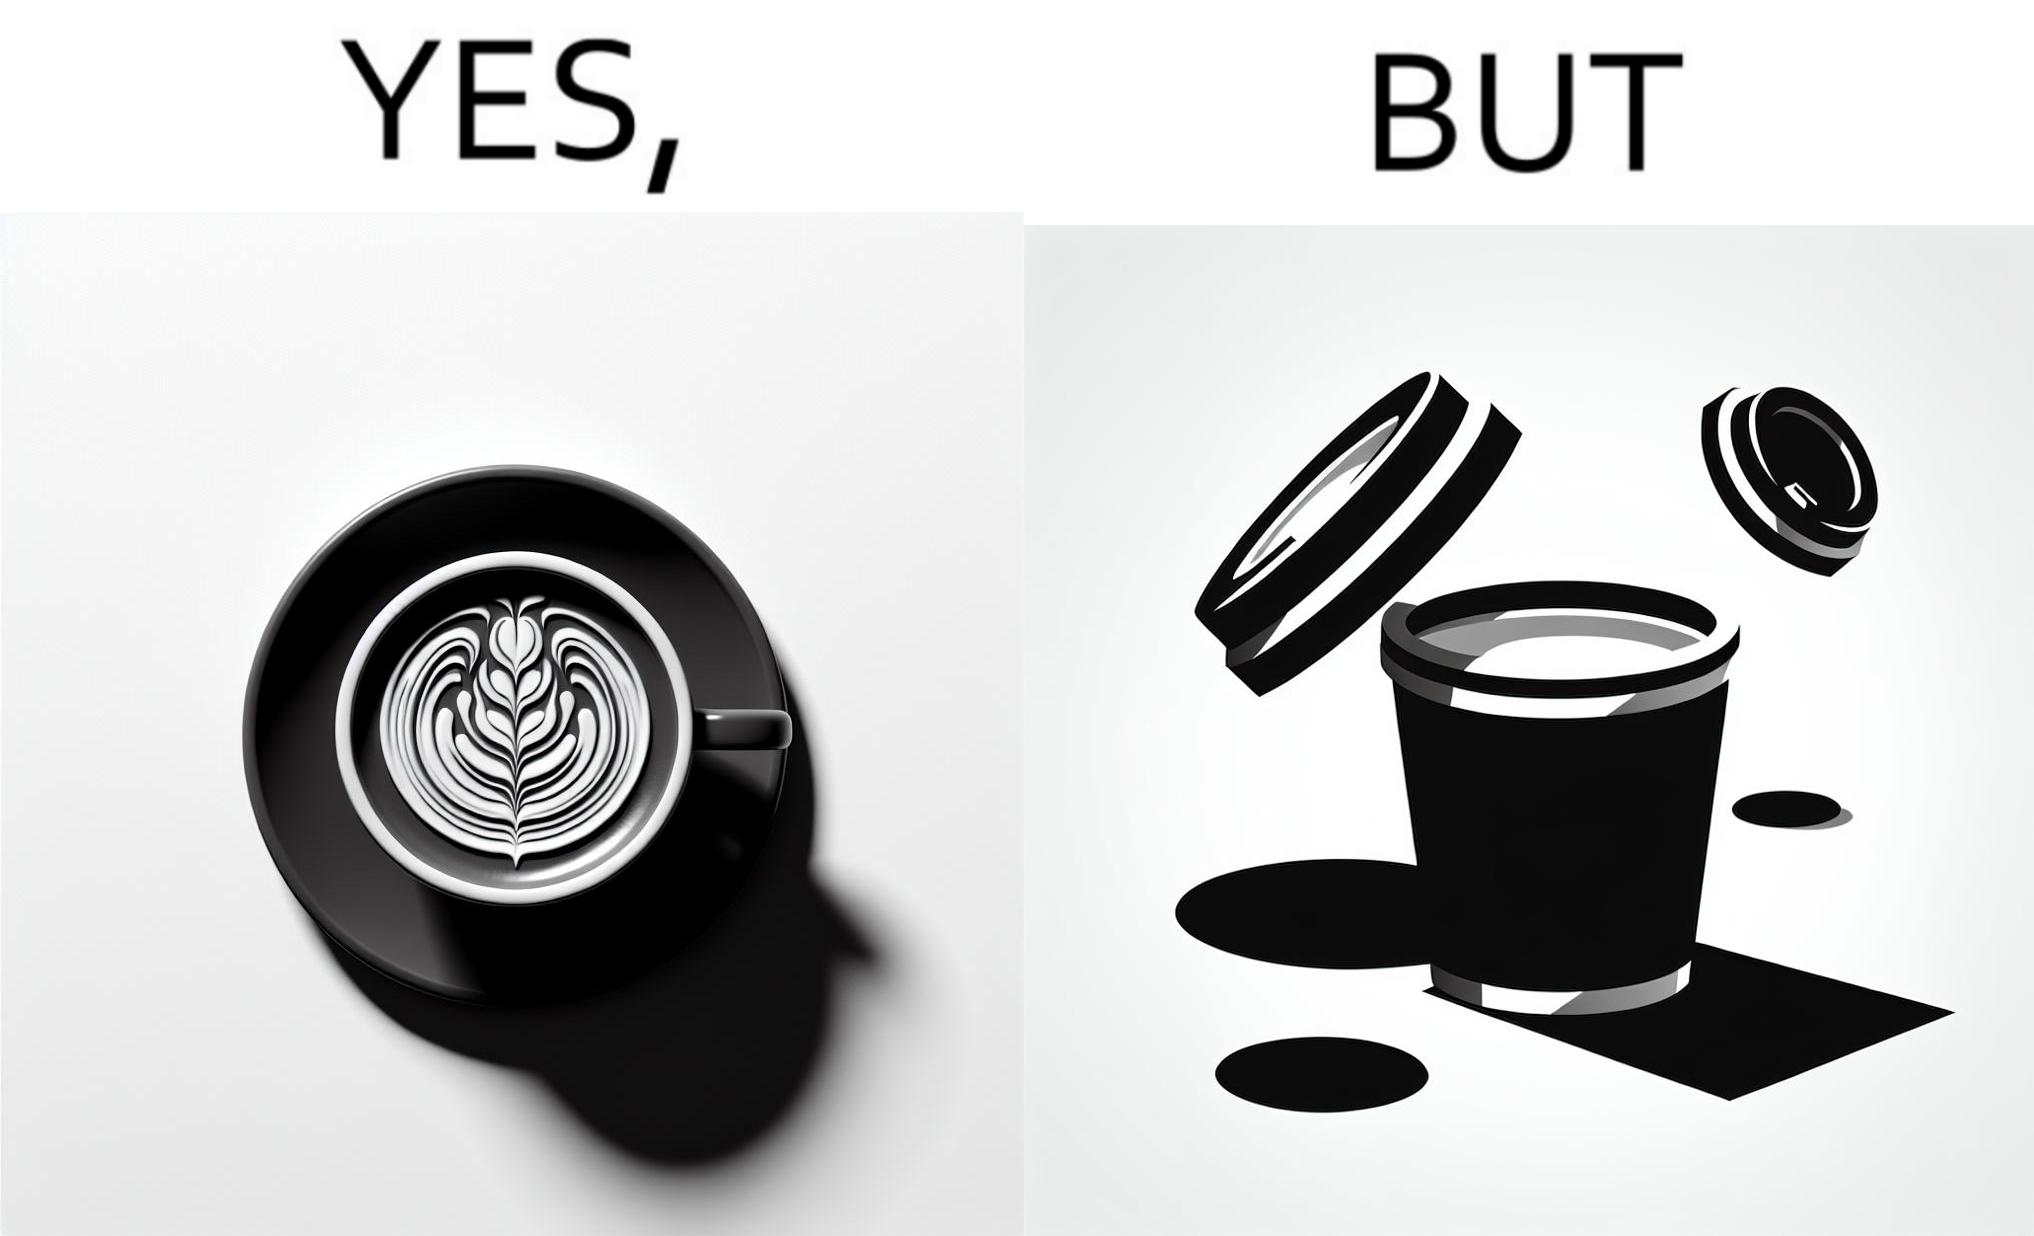Explain why this image is satirical. The images are funny since it shows how someone has put effort into a cup of coffee to do latte art on it only for it to be invisible after a lid is put on the coffee cup before serving to a customer 